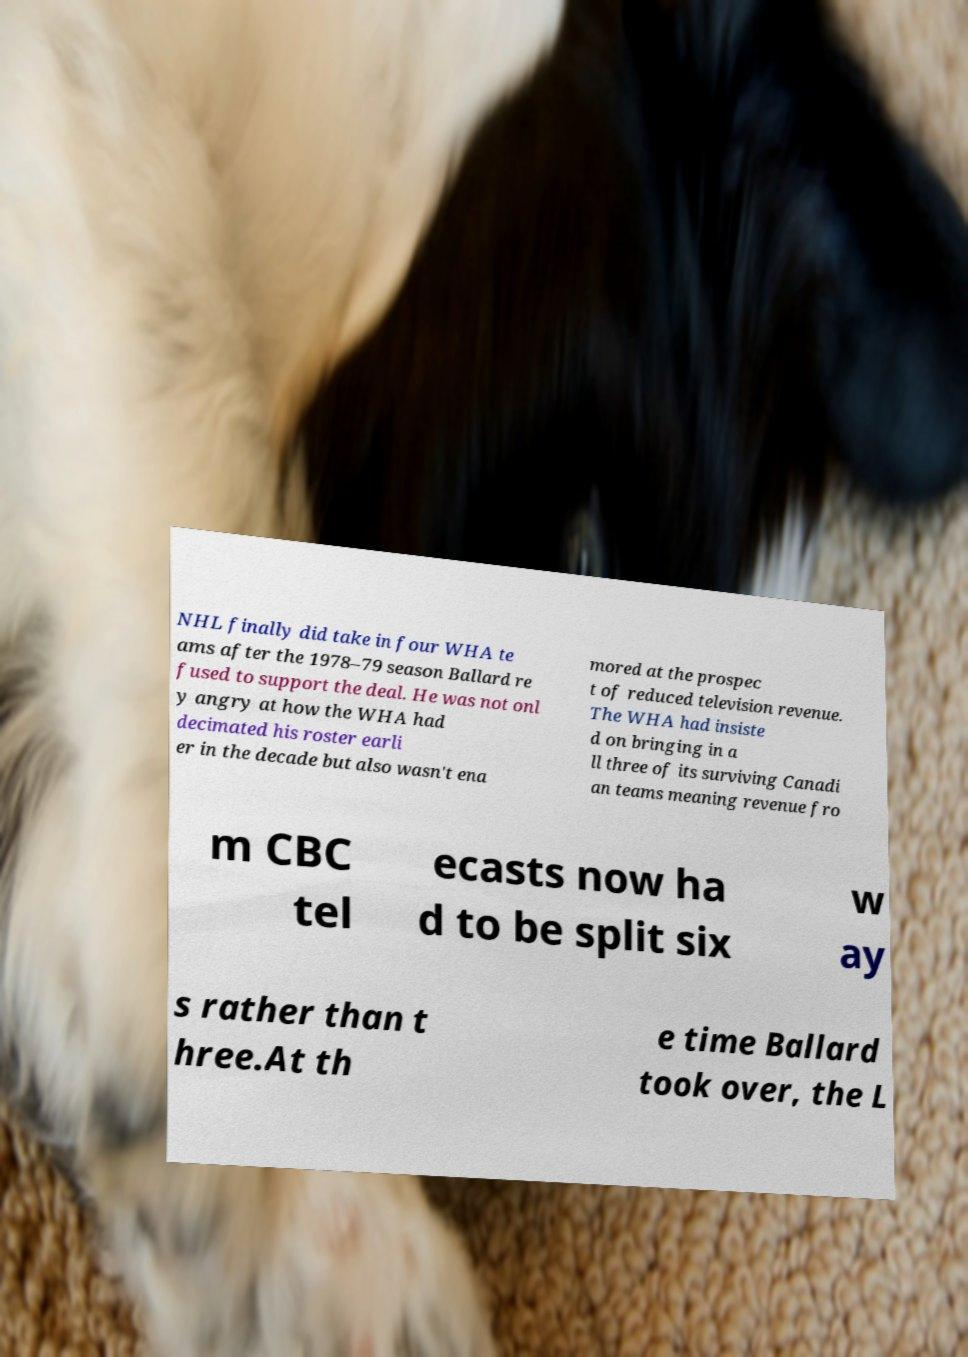Could you assist in decoding the text presented in this image and type it out clearly? NHL finally did take in four WHA te ams after the 1978–79 season Ballard re fused to support the deal. He was not onl y angry at how the WHA had decimated his roster earli er in the decade but also wasn't ena mored at the prospec t of reduced television revenue. The WHA had insiste d on bringing in a ll three of its surviving Canadi an teams meaning revenue fro m CBC tel ecasts now ha d to be split six w ay s rather than t hree.At th e time Ballard took over, the L 